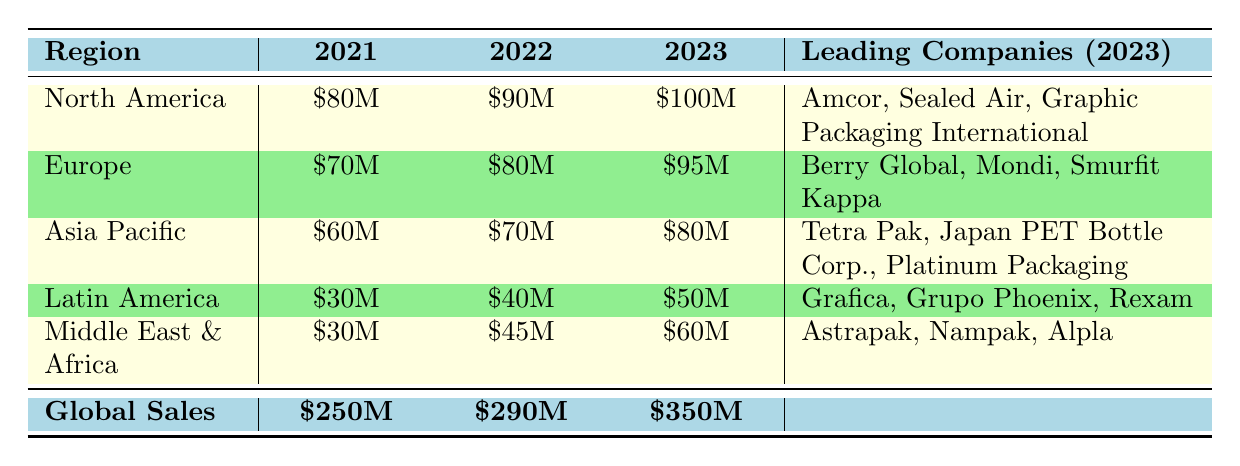What were the global sales in 2021? The table shows that the global sales for 2021 are listed directly under the "Global Sales" row in the "2021" column, which indicates the value as \$250M.
Answer: 250M Which region had the highest sales in 2022? Looking at the sales figures in the "2022" column, North America had the highest sales at \$90M, compared to other regions such as Europe (\$80M) and Asia Pacific (\$70M).
Answer: North America What is the total sales in Latin America over the three years? To find the total sales in Latin America, add the values for each year: 30M (2021) + 40M (2022) + 50M (2023) = 120M. This sum provides the total sales for the region across the three years.
Answer: 120M Did Europe experience a sales decrease from 2021 to 2023? The sales figures for Europe from 2021 to 2023 are \$70M, \$80M, and \$95M respectively. Since the values have increased each year, the statement is false.
Answer: No What is the overall percentage increase in global sales from 2021 to 2023? Calculate the increase by subtracting the sales of 2021 from 2023: 350M - 250M = 100M. Then, divide this increase by the 2021 sales and multiply by 100 to get the percentage: (100M/250M) * 100 = 40%.
Answer: 40% Which leading company in North America had the highest sales in 2023? The leading companies listed for North America in 2023 are Amcor, Sealed Air, and Graphic Packaging International. The exact sales figures aren't provided for each company, but they're leading in overall sales for the region in that year.
Answer: Amcor What was the sales trend in the Middle East and Africa over these three years? For Middle East & Africa, the sales figures show an increase: \$30M (2021), \$45M (2022), and \$60M (2023). Therefore, the trend is one of consistent growth.
Answer: Increasing trend Are the leading companies in Asia Pacific different in 2023 compared to 2021? In 2021, the leading companies were Tetra Pak, Japan PET Bottle Corp., and Toppan Printing. In 2023, the leading companies listed are Tetra Pak, Japan PET Bottle Corp., and Platinum Packaging. Since one company changed, the answer is yes.
Answer: Yes 